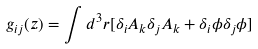Convert formula to latex. <formula><loc_0><loc_0><loc_500><loc_500>g _ { i j } ( z ) = \int d ^ { 3 } r [ \delta _ { i } A _ { k } \delta _ { j } A _ { k } + \delta _ { i } \phi \delta _ { j } \phi ]</formula> 